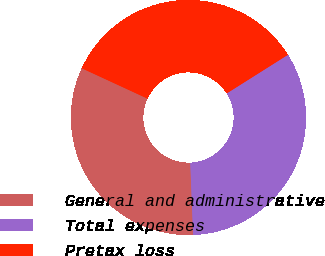<chart> <loc_0><loc_0><loc_500><loc_500><pie_chart><fcel>General and administrative<fcel>Total expenses<fcel>Pretax loss<nl><fcel>32.52%<fcel>33.33%<fcel>34.15%<nl></chart> 